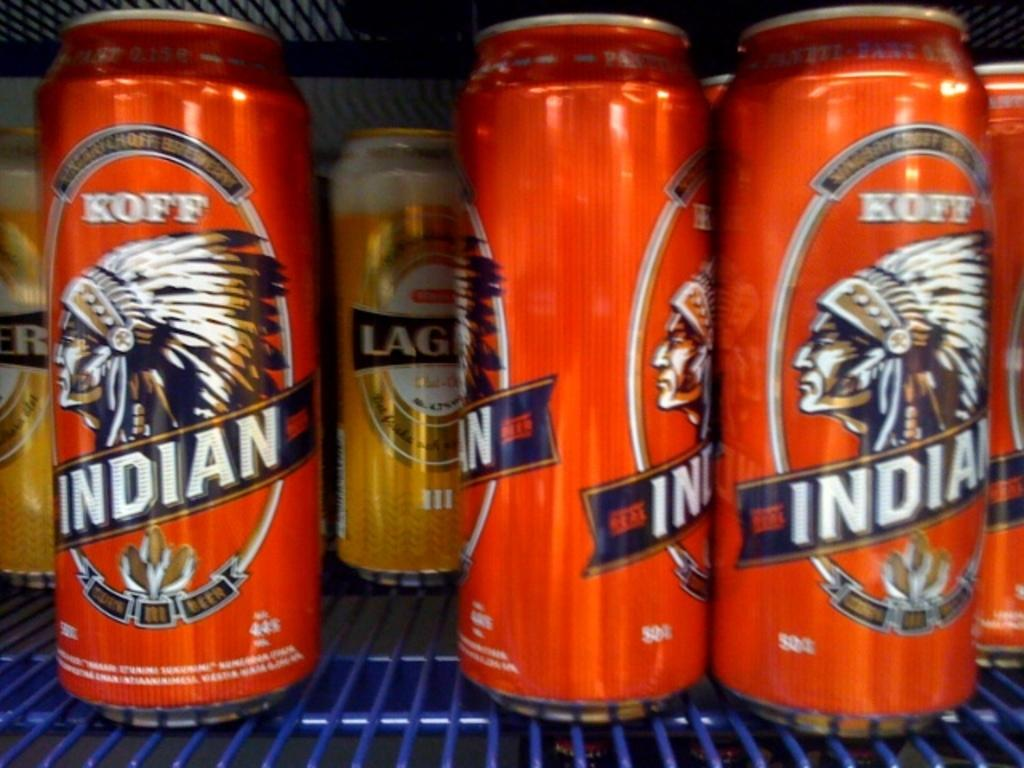<image>
Provide a brief description of the given image. some Indian cans that have a red background 